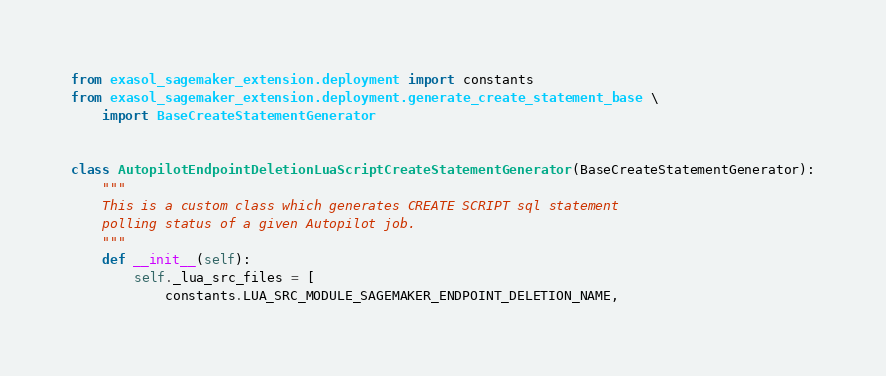Convert code to text. <code><loc_0><loc_0><loc_500><loc_500><_Python_>from exasol_sagemaker_extension.deployment import constants
from exasol_sagemaker_extension.deployment.generate_create_statement_base \
    import BaseCreateStatementGenerator


class AutopilotEndpointDeletionLuaScriptCreateStatementGenerator(BaseCreateStatementGenerator):
    """
    This is a custom class which generates CREATE SCRIPT sql statement
    polling status of a given Autopilot job.
    """
    def __init__(self):
        self._lua_src_files = [
            constants.LUA_SRC_MODULE_SAGEMAKER_ENDPOINT_DELETION_NAME,</code> 